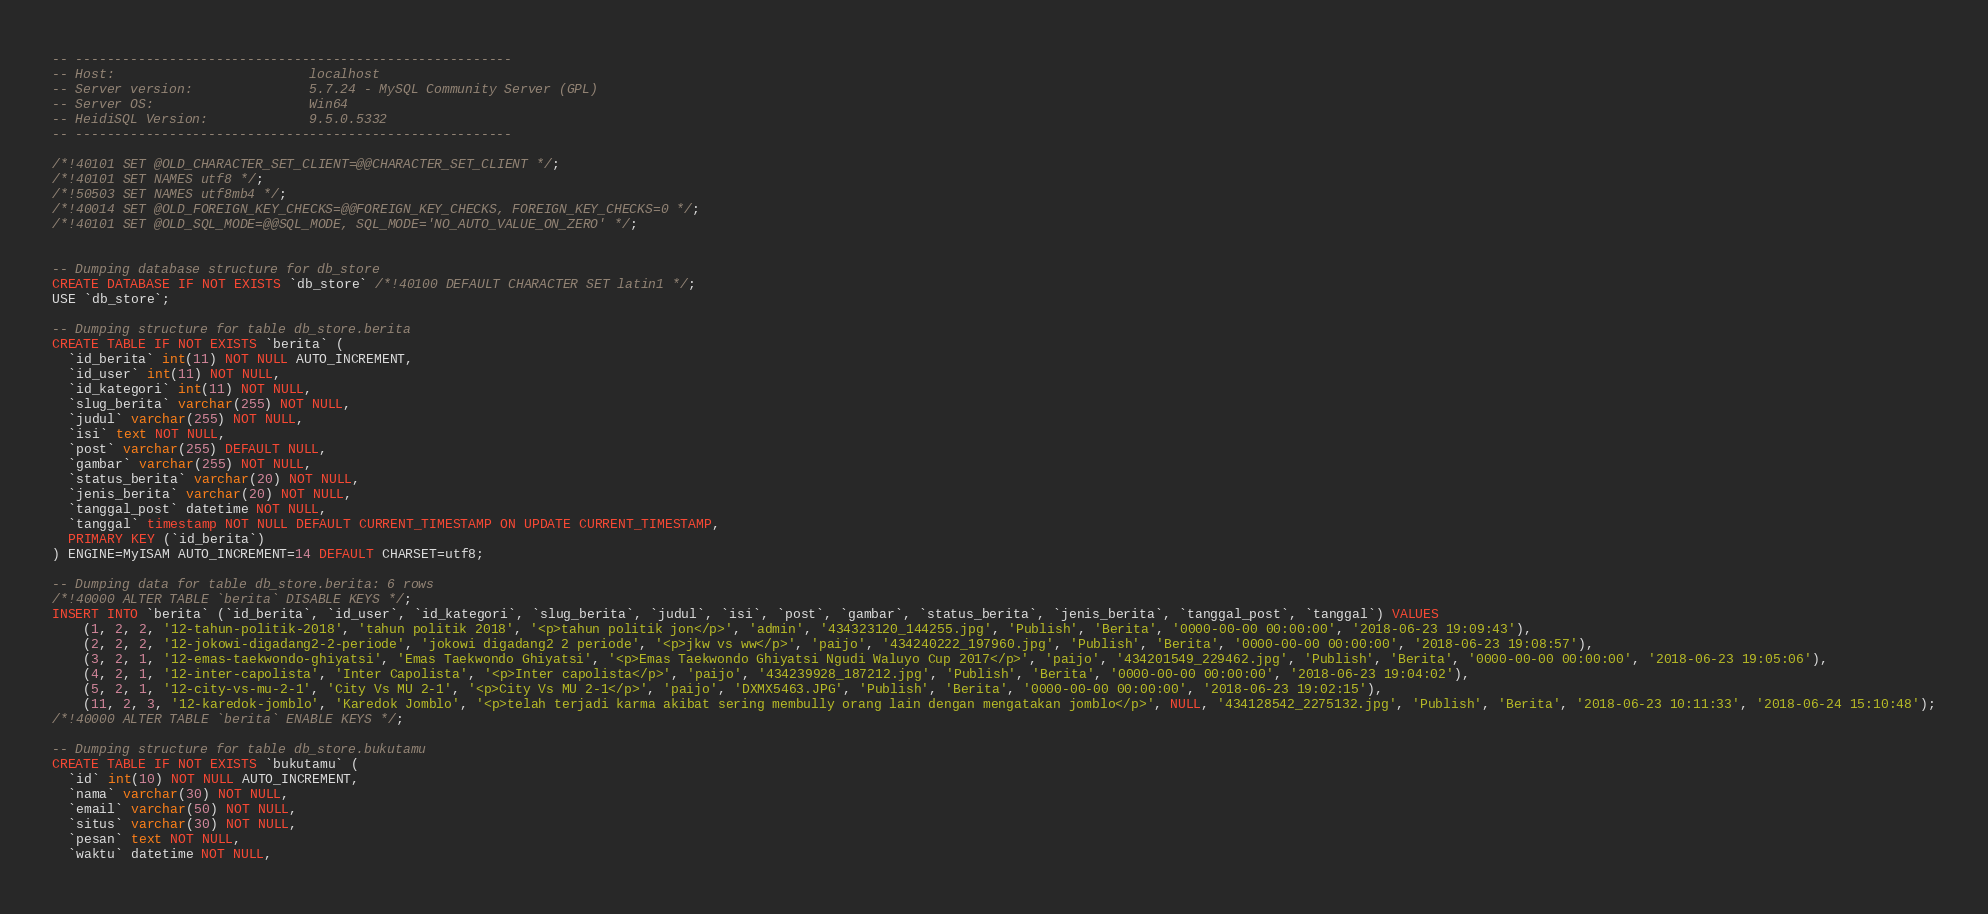Convert code to text. <code><loc_0><loc_0><loc_500><loc_500><_SQL_>-- --------------------------------------------------------
-- Host:                         localhost
-- Server version:               5.7.24 - MySQL Community Server (GPL)
-- Server OS:                    Win64
-- HeidiSQL Version:             9.5.0.5332
-- --------------------------------------------------------

/*!40101 SET @OLD_CHARACTER_SET_CLIENT=@@CHARACTER_SET_CLIENT */;
/*!40101 SET NAMES utf8 */;
/*!50503 SET NAMES utf8mb4 */;
/*!40014 SET @OLD_FOREIGN_KEY_CHECKS=@@FOREIGN_KEY_CHECKS, FOREIGN_KEY_CHECKS=0 */;
/*!40101 SET @OLD_SQL_MODE=@@SQL_MODE, SQL_MODE='NO_AUTO_VALUE_ON_ZERO' */;


-- Dumping database structure for db_store
CREATE DATABASE IF NOT EXISTS `db_store` /*!40100 DEFAULT CHARACTER SET latin1 */;
USE `db_store`;

-- Dumping structure for table db_store.berita
CREATE TABLE IF NOT EXISTS `berita` (
  `id_berita` int(11) NOT NULL AUTO_INCREMENT,
  `id_user` int(11) NOT NULL,
  `id_kategori` int(11) NOT NULL,
  `slug_berita` varchar(255) NOT NULL,
  `judul` varchar(255) NOT NULL,
  `isi` text NOT NULL,
  `post` varchar(255) DEFAULT NULL,
  `gambar` varchar(255) NOT NULL,
  `status_berita` varchar(20) NOT NULL,
  `jenis_berita` varchar(20) NOT NULL,
  `tanggal_post` datetime NOT NULL,
  `tanggal` timestamp NOT NULL DEFAULT CURRENT_TIMESTAMP ON UPDATE CURRENT_TIMESTAMP,
  PRIMARY KEY (`id_berita`)
) ENGINE=MyISAM AUTO_INCREMENT=14 DEFAULT CHARSET=utf8;

-- Dumping data for table db_store.berita: 6 rows
/*!40000 ALTER TABLE `berita` DISABLE KEYS */;
INSERT INTO `berita` (`id_berita`, `id_user`, `id_kategori`, `slug_berita`, `judul`, `isi`, `post`, `gambar`, `status_berita`, `jenis_berita`, `tanggal_post`, `tanggal`) VALUES
	(1, 2, 2, '12-tahun-politik-2018', 'tahun politik 2018', '<p>tahun politik jon</p>', 'admin', '434323120_144255.jpg', 'Publish', 'Berita', '0000-00-00 00:00:00', '2018-06-23 19:09:43'),
	(2, 2, 2, '12-jokowi-digadang2-2-periode', 'jokowi digadang2 2 periode', '<p>jkw vs ww</p>', 'paijo', '434240222_197960.jpg', 'Publish', 'Berita', '0000-00-00 00:00:00', '2018-06-23 19:08:57'),
	(3, 2, 1, '12-emas-taekwondo-ghiyatsi', 'Emas Taekwondo Ghiyatsi', '<p>Emas Taekwondo Ghiyatsi Ngudi Waluyo Cup 2017</p>', 'paijo', '434201549_229462.jpg', 'Publish', 'Berita', '0000-00-00 00:00:00', '2018-06-23 19:05:06'),
	(4, 2, 1, '12-inter-capolista', 'Inter Capolista', '<p>Inter capolista</p>', 'paijo', '434239928_187212.jpg', 'Publish', 'Berita', '0000-00-00 00:00:00', '2018-06-23 19:04:02'),
	(5, 2, 1, '12-city-vs-mu-2-1', 'City Vs MU 2-1', '<p>City Vs MU 2-1</p>', 'paijo', 'DXMX5463.JPG', 'Publish', 'Berita', '0000-00-00 00:00:00', '2018-06-23 19:02:15'),
	(11, 2, 3, '12-karedok-jomblo', 'Karedok Jomblo', '<p>telah terjadi karma akibat sering membully orang lain dengan mengatakan jomblo</p>', NULL, '434128542_2275132.jpg', 'Publish', 'Berita', '2018-06-23 10:11:33', '2018-06-24 15:10:48');
/*!40000 ALTER TABLE `berita` ENABLE KEYS */;

-- Dumping structure for table db_store.bukutamu
CREATE TABLE IF NOT EXISTS `bukutamu` (
  `id` int(10) NOT NULL AUTO_INCREMENT,
  `nama` varchar(30) NOT NULL,
  `email` varchar(50) NOT NULL,
  `situs` varchar(30) NOT NULL,
  `pesan` text NOT NULL,
  `waktu` datetime NOT NULL,</code> 